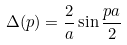Convert formula to latex. <formula><loc_0><loc_0><loc_500><loc_500>\Delta ( p ) = \frac { 2 } { a } \sin \frac { p a } { 2 }</formula> 